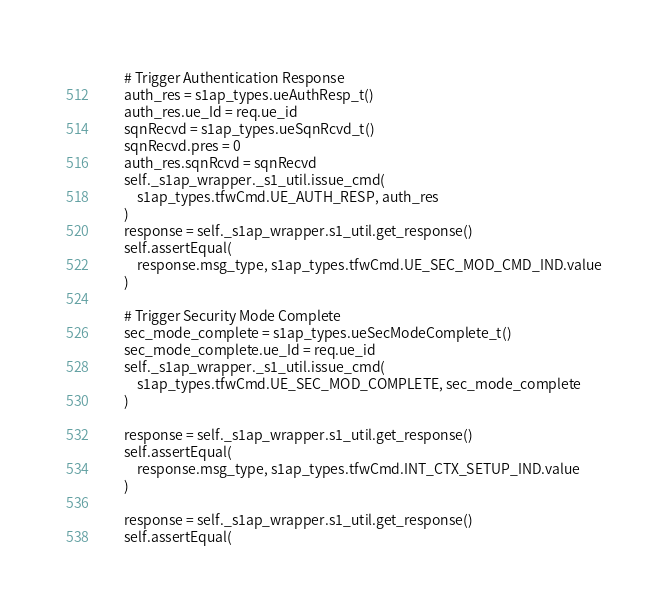Convert code to text. <code><loc_0><loc_0><loc_500><loc_500><_Python_>        # Trigger Authentication Response
        auth_res = s1ap_types.ueAuthResp_t()
        auth_res.ue_Id = req.ue_id
        sqnRecvd = s1ap_types.ueSqnRcvd_t()
        sqnRecvd.pres = 0
        auth_res.sqnRcvd = sqnRecvd
        self._s1ap_wrapper._s1_util.issue_cmd(
            s1ap_types.tfwCmd.UE_AUTH_RESP, auth_res
        )
        response = self._s1ap_wrapper.s1_util.get_response()
        self.assertEqual(
            response.msg_type, s1ap_types.tfwCmd.UE_SEC_MOD_CMD_IND.value
        )

        # Trigger Security Mode Complete
        sec_mode_complete = s1ap_types.ueSecModeComplete_t()
        sec_mode_complete.ue_Id = req.ue_id
        self._s1ap_wrapper._s1_util.issue_cmd(
            s1ap_types.tfwCmd.UE_SEC_MOD_COMPLETE, sec_mode_complete
        )

        response = self._s1ap_wrapper.s1_util.get_response()
        self.assertEqual(
            response.msg_type, s1ap_types.tfwCmd.INT_CTX_SETUP_IND.value
        )

        response = self._s1ap_wrapper.s1_util.get_response()
        self.assertEqual(</code> 